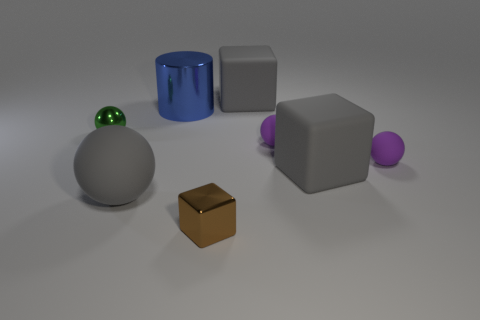Add 1 tiny green metal objects. How many objects exist? 9 Subtract all blocks. How many objects are left? 5 Add 2 blue metallic things. How many blue metallic things are left? 3 Add 3 small red rubber cubes. How many small red rubber cubes exist? 3 Subtract 0 cyan cylinders. How many objects are left? 8 Subtract all tiny rubber balls. Subtract all blue metal cylinders. How many objects are left? 5 